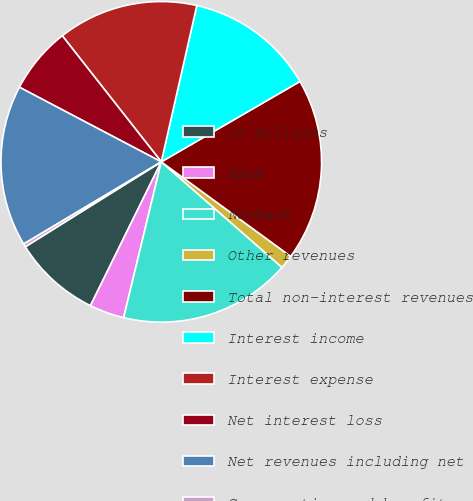Convert chart. <chart><loc_0><loc_0><loc_500><loc_500><pie_chart><fcel>in millions<fcel>Bank<fcel>Nonbank<fcel>Other revenues<fcel>Total non-interest revenues<fcel>Interest income<fcel>Interest expense<fcel>Net interest loss<fcel>Net revenues including net<fcel>Compensation and benefits<nl><fcel>8.83%<fcel>3.51%<fcel>17.34%<fcel>1.39%<fcel>18.4%<fcel>13.08%<fcel>14.15%<fcel>6.7%<fcel>16.27%<fcel>0.32%<nl></chart> 